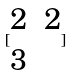Convert formula to latex. <formula><loc_0><loc_0><loc_500><loc_500>[ \begin{matrix} 2 & 2 \\ 3 \end{matrix} ]</formula> 